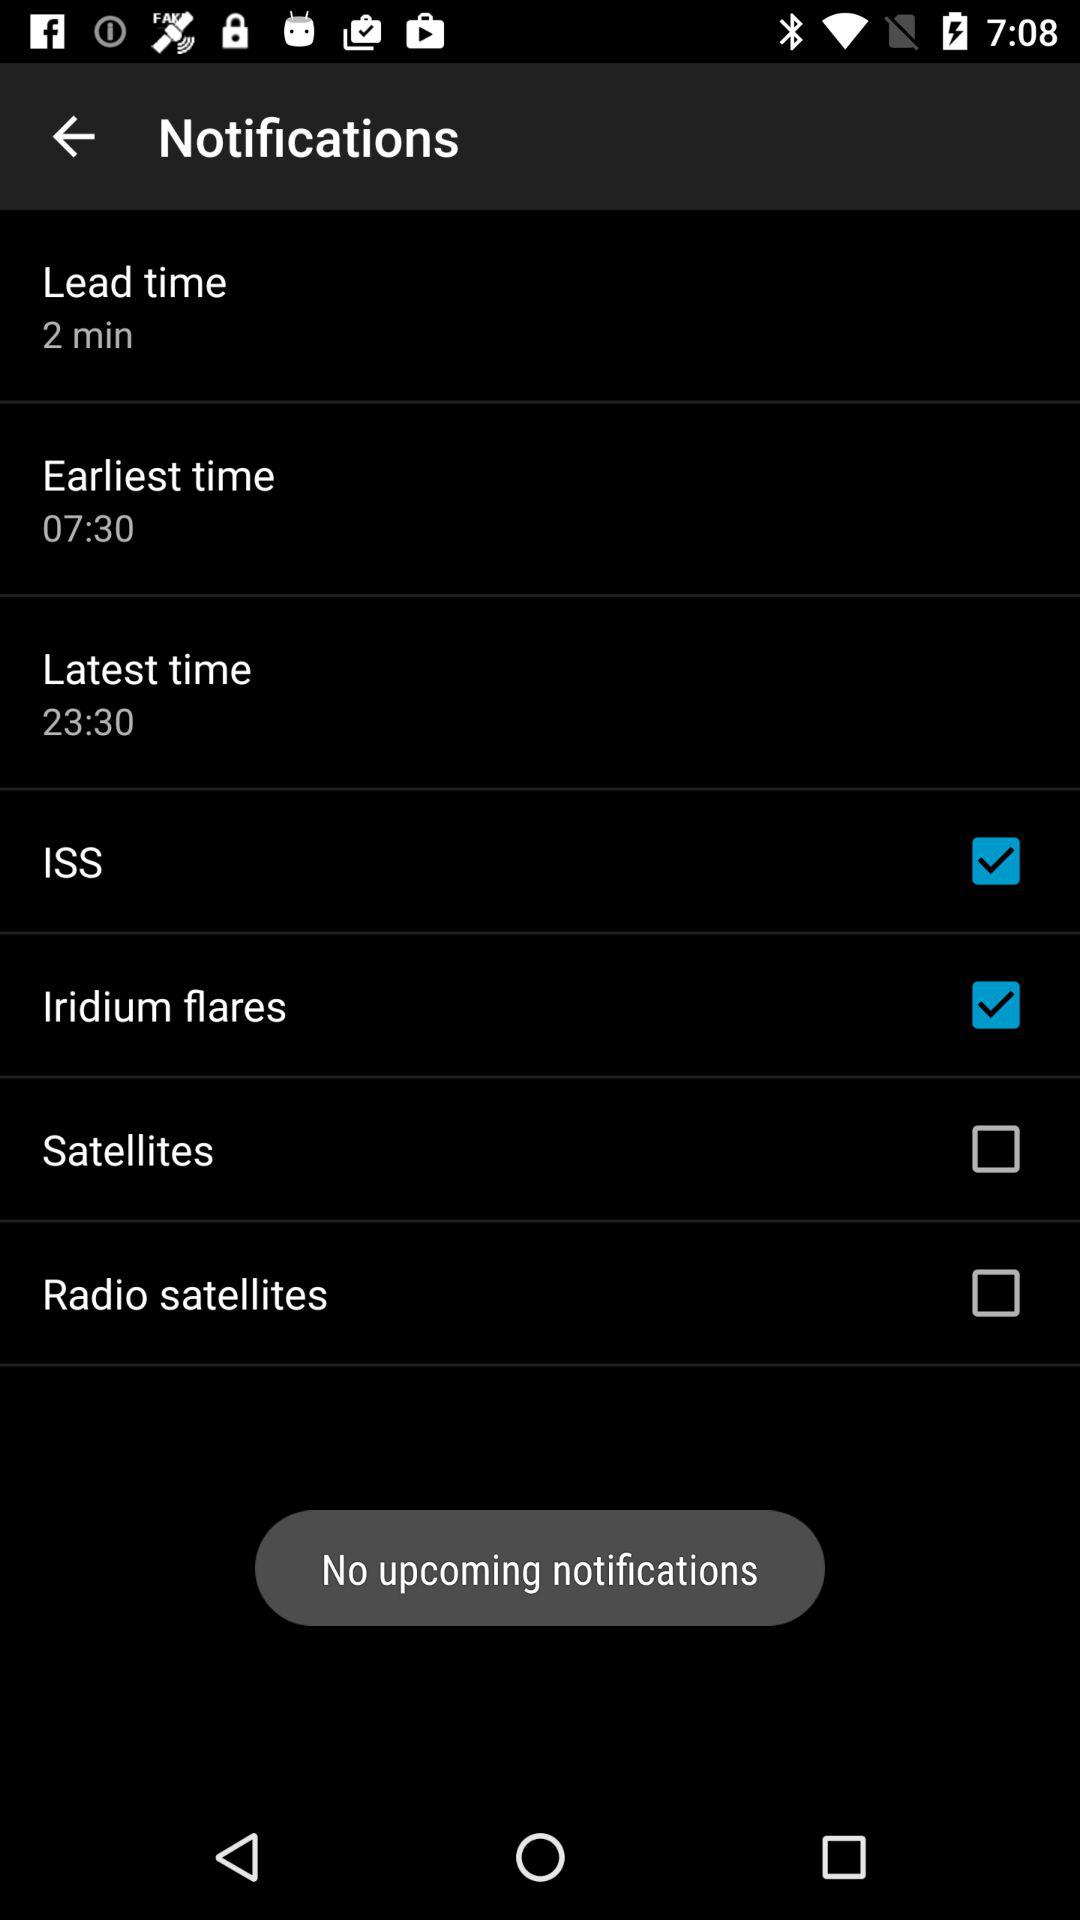What is the latest time? The latest time is 23:30. 